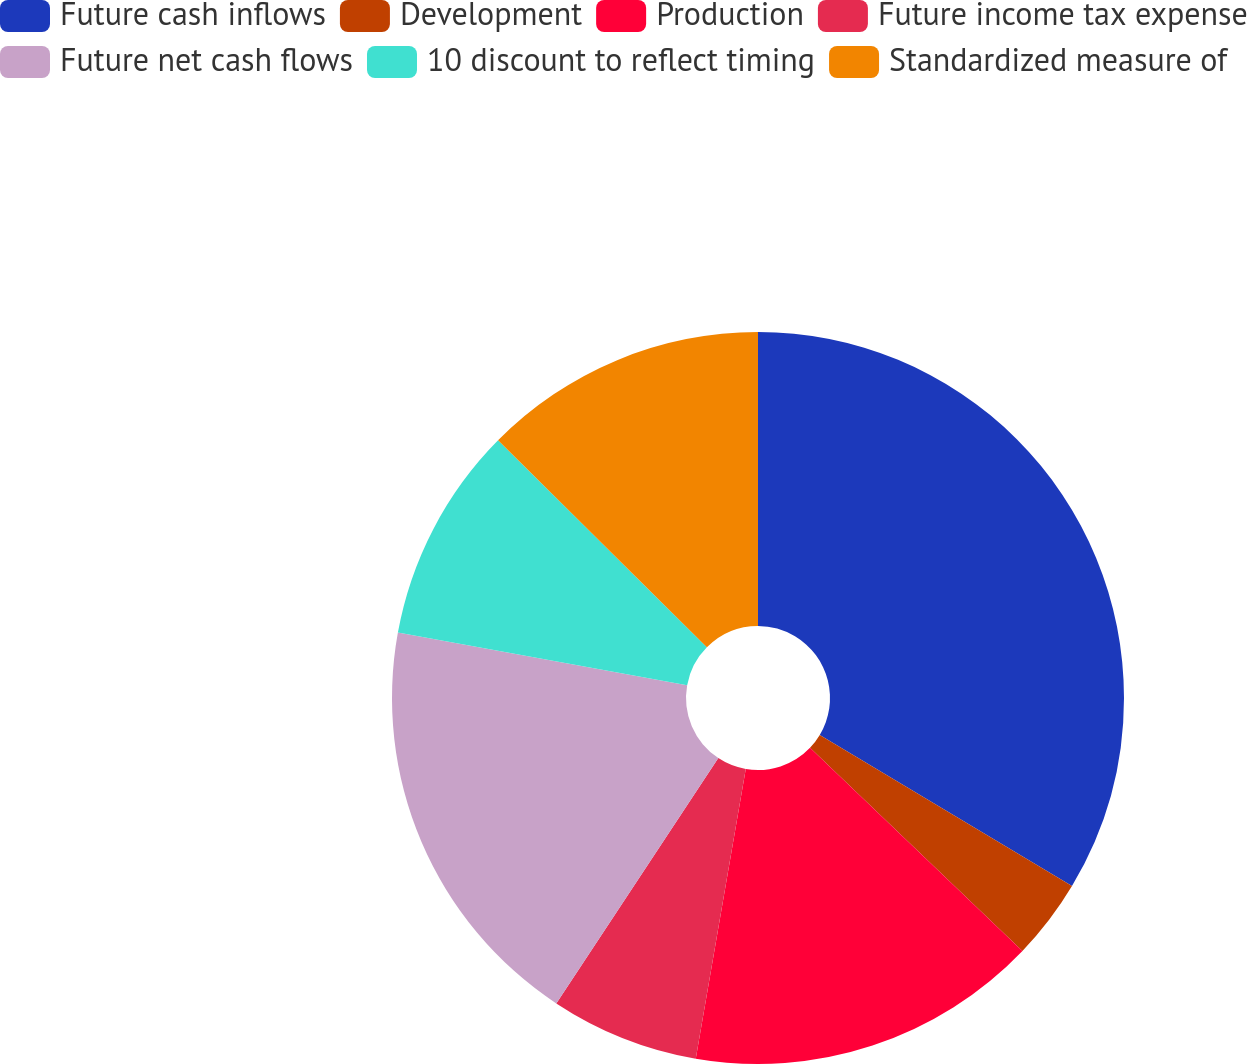Convert chart. <chart><loc_0><loc_0><loc_500><loc_500><pie_chart><fcel>Future cash inflows<fcel>Development<fcel>Production<fcel>Future income tax expense<fcel>Future net cash flows<fcel>10 discount to reflect timing<fcel>Standardized measure of<nl><fcel>33.59%<fcel>3.56%<fcel>15.57%<fcel>6.57%<fcel>18.57%<fcel>9.57%<fcel>12.57%<nl></chart> 